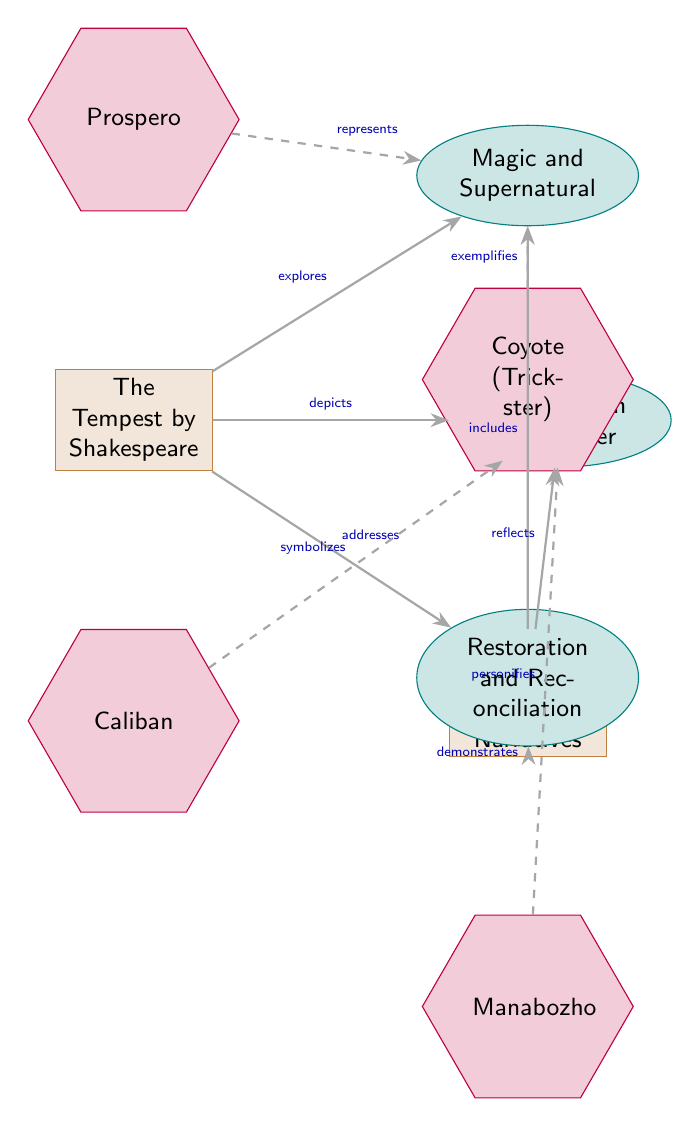What are the themes explored in "The Tempest"? The diagram shows that "The Tempest" explores the themes of magic and supernatural, colonization and power, and restoration and reconciliation.
Answer: Magic and Supernatural, Colonization and Power, Restoration and Reconciliation How many characters are represented in the diagram? The diagram identifies four characters: Prospero, Caliban, Coyote, and Manabozho, thus there are four characters represented.
Answer: 4 What does Caliban symbolize in "The Tempest"? According to the diagram, Caliban symbolizes colonization in "The Tempest".
Answer: Colonization Which character exemplifies magic in Native American oral narratives? The diagram indicates that Coyote exemplifies magic in Native American oral narratives.
Answer: Coyote What type of relationship does "Native American Oral Narratives" have with the theme of restoration? The diagram states that "Native American Oral Narratives" demonstrates the theme of restoration.
Answer: Demonstrates How many relationships are depicted between the literatures and themes? There are six relationships between "The Tempest," "Native American Oral Narratives," and the themes represented in the diagram.
Answer: 6 Which character in "The Tempest" represents magic? The diagram shows that Prospero represents magic in "The Tempest".
Answer: Prospero What relationship does the theme of colonization have with Native American oral narratives? The diagram indicates that Native American oral narratives reflect colonization.
Answer: Reflects Which theme is addressed by both "The Tempest" and Native American narratives? Both "The Tempest" and Native American narratives address the theme of restoration.
Answer: Restoration 